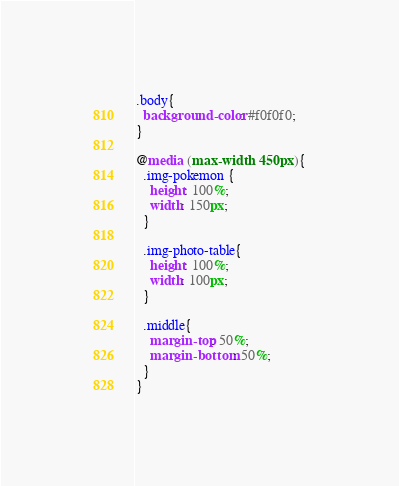<code> <loc_0><loc_0><loc_500><loc_500><_CSS_>
.body{
  background-color: #f0f0f0;
}

@media (max-width: 450px){
  .img-pokemon {
    height: 100%;
    width: 150px;
  }

  .img-photo-table{
    height: 100%;
    width: 100px;
  }

  .middle{
    margin-top: 50%;
    margin-bottom: 50%;
  }
}</code> 